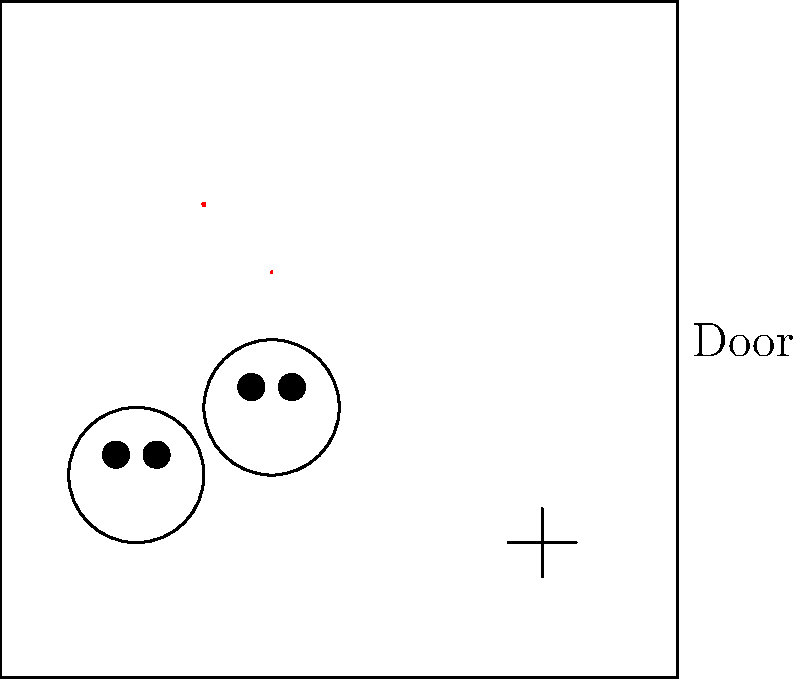Based on the visual evidence presented in this crime scene diagram, which type of forensic analysis would be most crucial for identifying the perpetrator? To determine the most crucial type of forensic analysis for identifying the perpetrator, let's analyze the visual evidence step by step:

1. Blood spatter: There are two distinct blood splatters visible in the upper left quadrant of the scene. While important, blood evidence typically requires DNA analysis, which can be time-consuming and may not immediately lead to suspect identification.

2. Fingerprint: A clear fingerprint is visible in the lower right quadrant. Fingerprints are unique to individuals and can be quickly compared against databases for identification.

3. Footprints: Two footprints are visible in the lower left quadrant. While footprints can provide information about the perpetrator's shoe size and movement, they are less individualized than fingerprints.

4. Door: The presence of a door suggests potential for additional evidence (e.g., doorknob fingerprints), but no specific evidence is visible.

Given these observations, fingerprint analysis would be the most crucial for identifying the perpetrator because:

a) Fingerprints are highly individualized and can provide a direct link to a specific person.
b) Fingerprint databases are extensive and can be searched quickly.
c) The clear, visible fingerprint in the scene suggests it was left intact, increasing the likelihood of a successful match.
d) Compared to DNA analysis from blood evidence, fingerprint analysis is typically faster and can provide more immediate results for identification purposes.

While all evidence is important, the fingerprint offers the most direct and efficient path to potentially identifying the perpetrator in this scenario.
Answer: Fingerprint analysis 